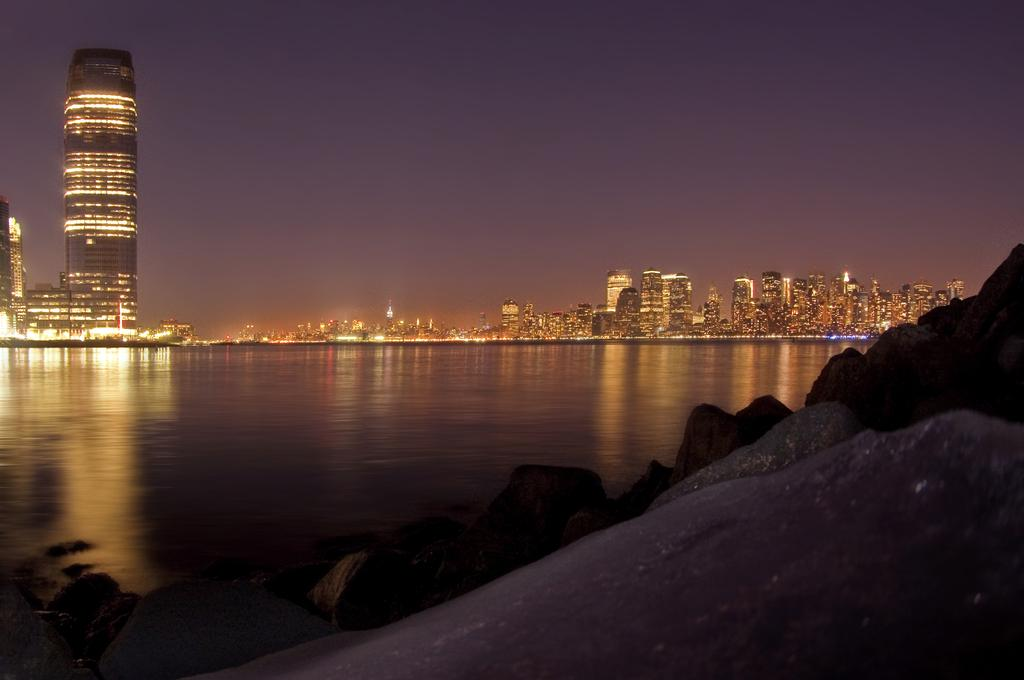What type of natural feature can be seen on the right side of the image? There are rocks on the right side of the image. What is the liquid element visible in the image? There is water visible in the image. What type of man-made structures can be seen in the background of the image? There are buildings with lights in the background. What is visible at the top of the image? The sky is visible at the top of the image. What type of needle can be seen in the image? There is no needle present in the image. What route are the rocks taking in the image? The rocks are stationary in the image and do not take a route. 